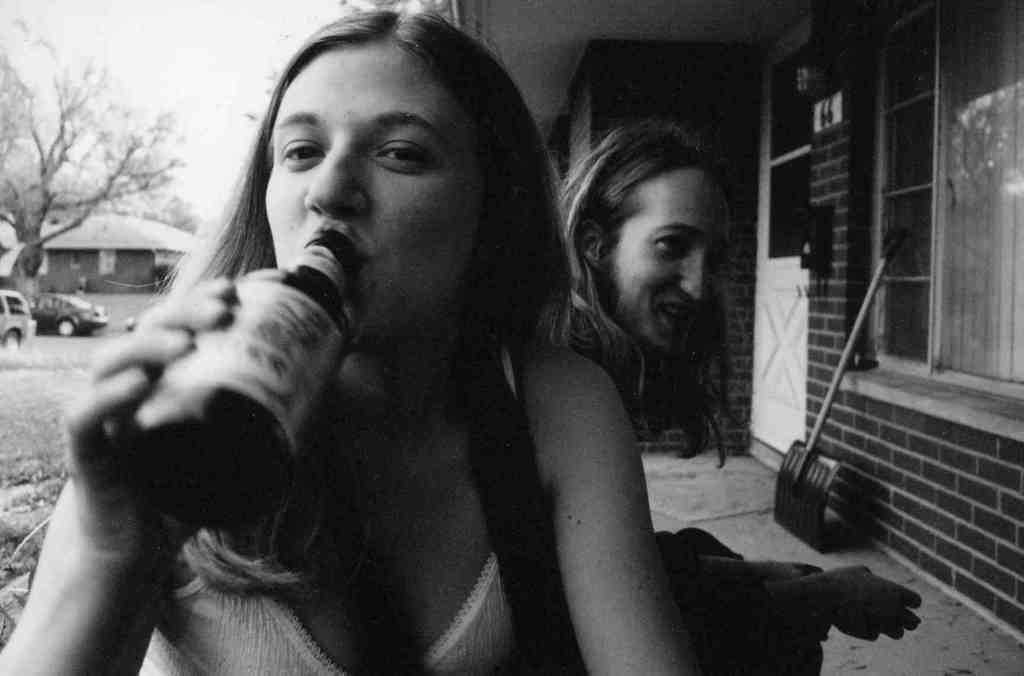Can you describe this image briefly? This image consists of two girls. In the front, the girl is holding a bottle and drinking. On the right, we can see a wall along with a window and a door. At the bottom, there is a floor. On the left, we can see two vehicles parked on the ground. And there is a tree along with a hut. At the top, there is sky. 